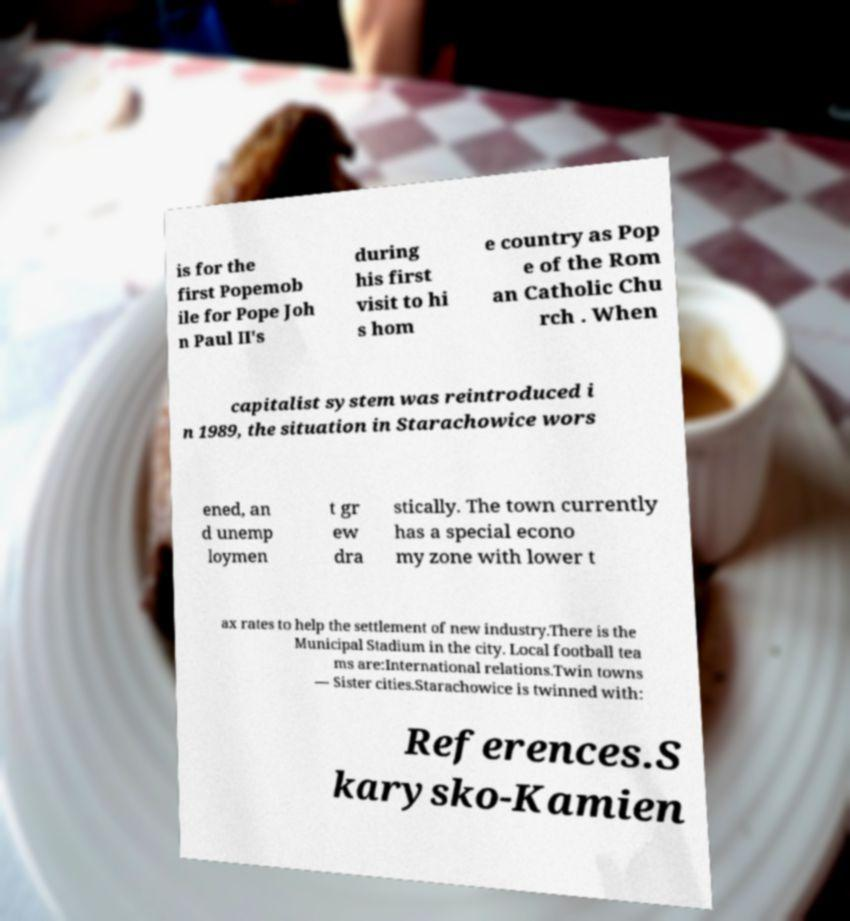There's text embedded in this image that I need extracted. Can you transcribe it verbatim? is for the first Popemob ile for Pope Joh n Paul II's during his first visit to hi s hom e country as Pop e of the Rom an Catholic Chu rch . When capitalist system was reintroduced i n 1989, the situation in Starachowice wors ened, an d unemp loymen t gr ew dra stically. The town currently has a special econo my zone with lower t ax rates to help the settlement of new industry.There is the Municipal Stadium in the city. Local football tea ms are:International relations.Twin towns — Sister cities.Starachowice is twinned with: References.S karysko-Kamien 